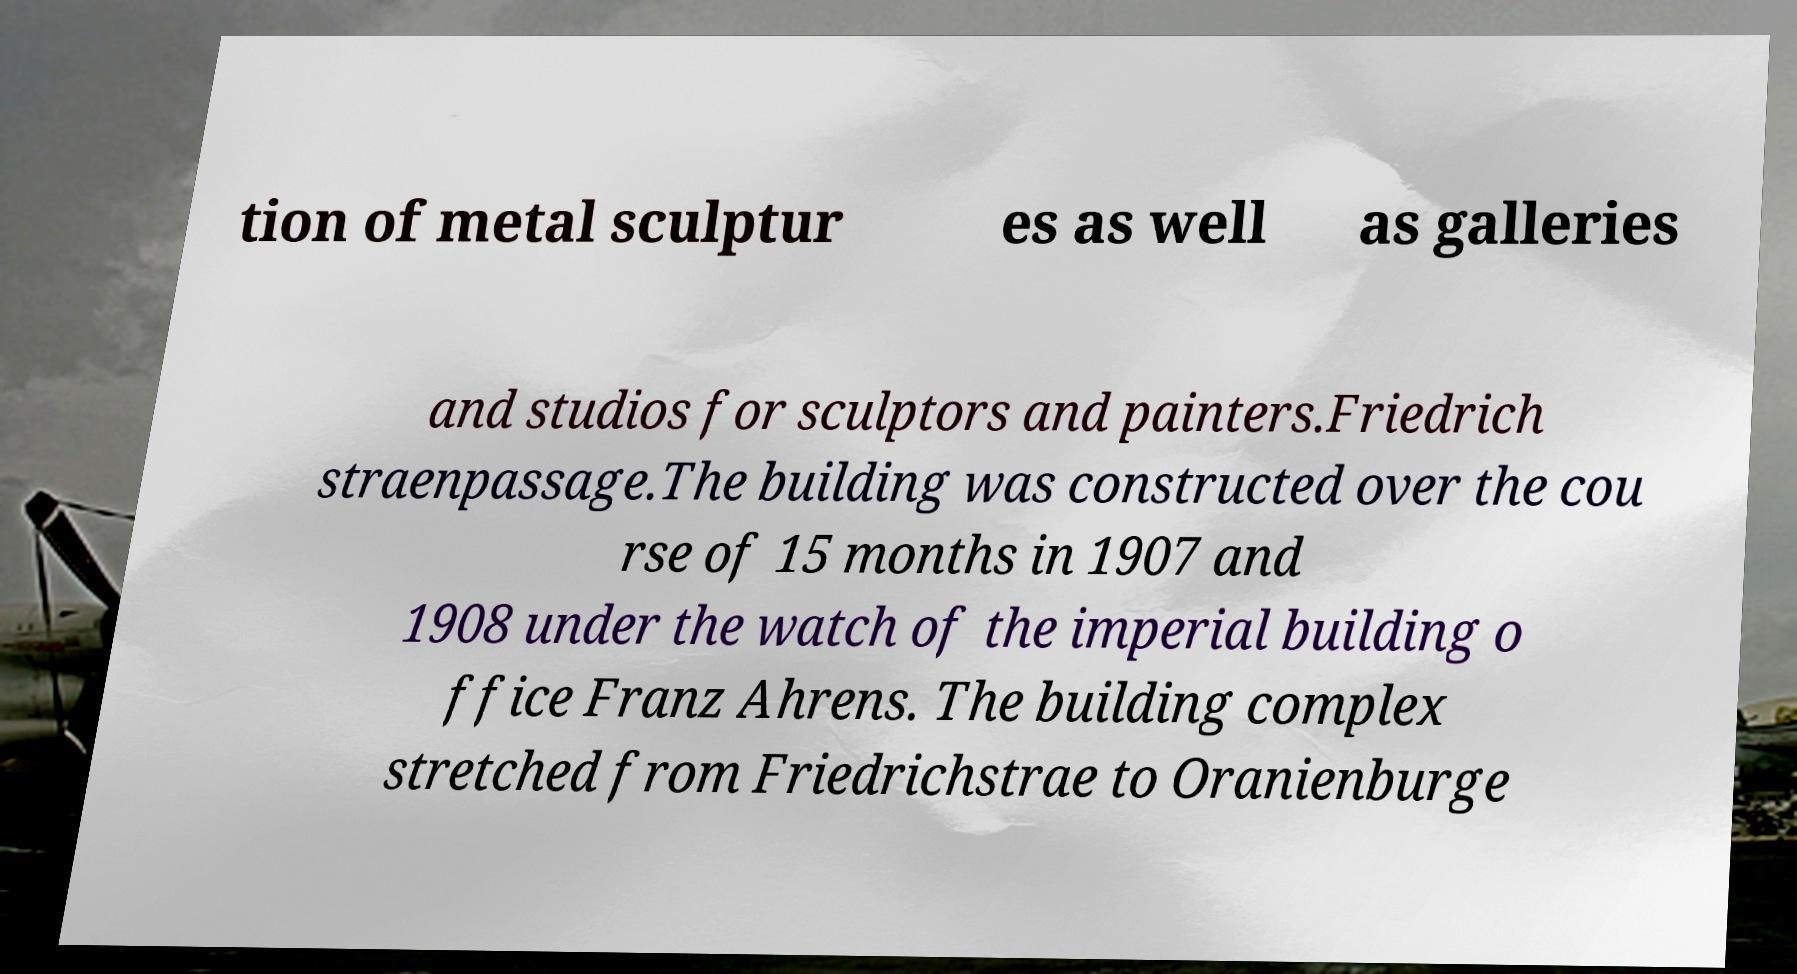I need the written content from this picture converted into text. Can you do that? tion of metal sculptur es as well as galleries and studios for sculptors and painters.Friedrich straenpassage.The building was constructed over the cou rse of 15 months in 1907 and 1908 under the watch of the imperial building o ffice Franz Ahrens. The building complex stretched from Friedrichstrae to Oranienburge 